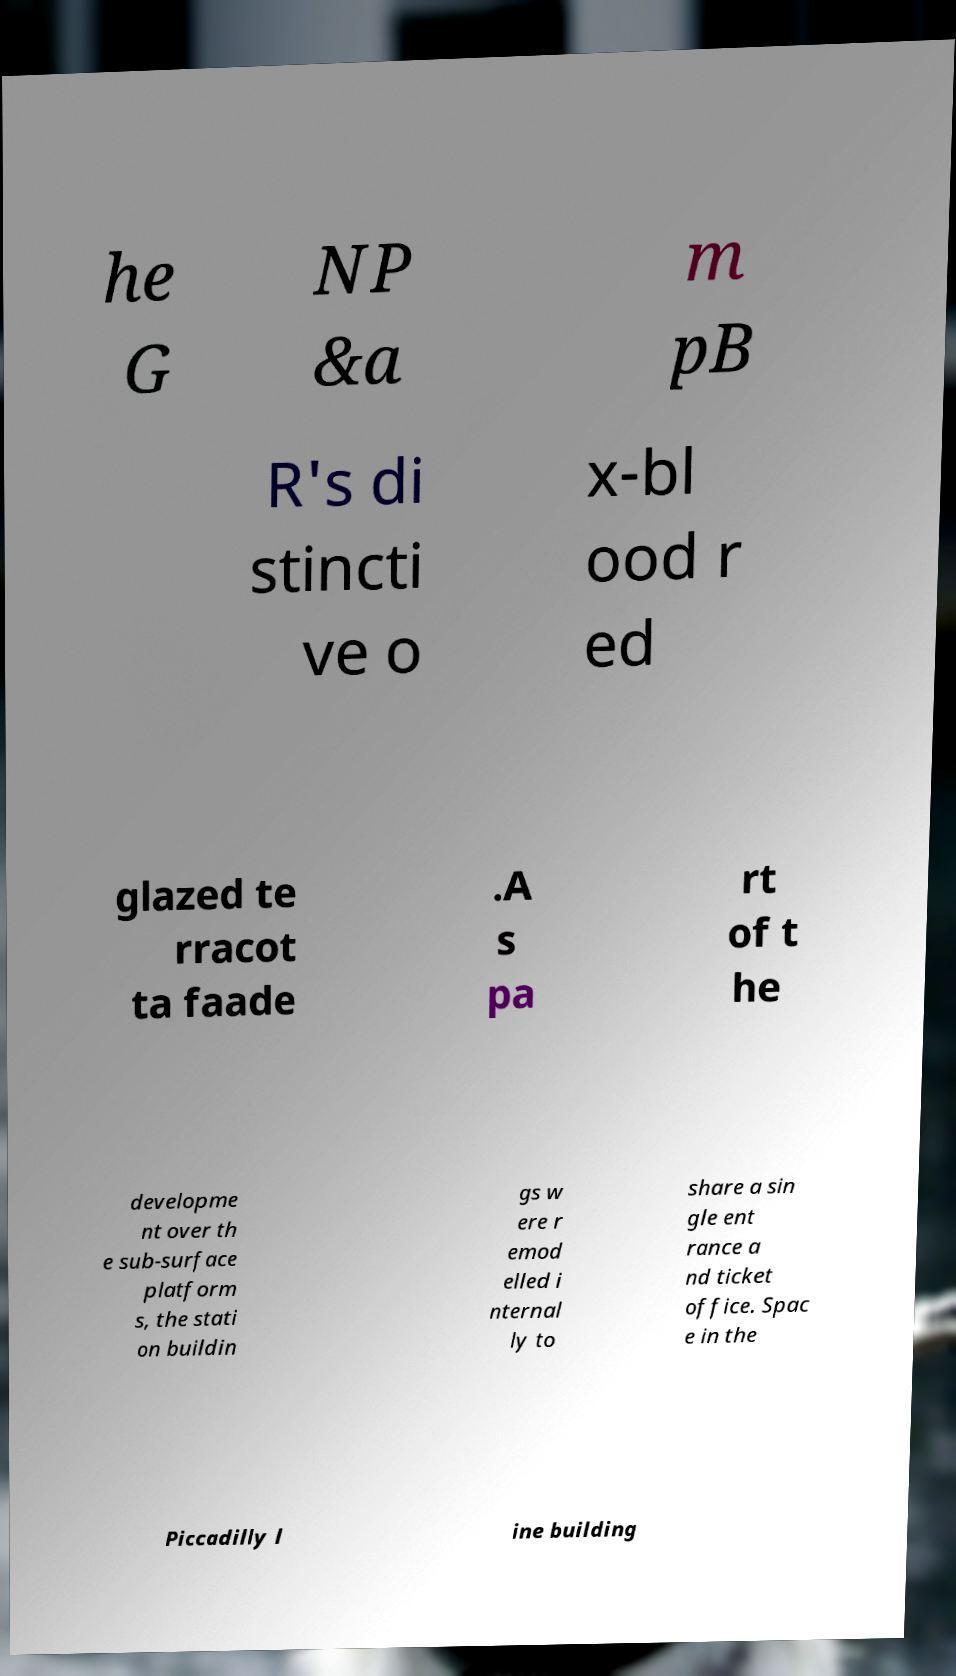Can you read and provide the text displayed in the image?This photo seems to have some interesting text. Can you extract and type it out for me? he G NP &a m pB R's di stincti ve o x-bl ood r ed glazed te rracot ta faade .A s pa rt of t he developme nt over th e sub-surface platform s, the stati on buildin gs w ere r emod elled i nternal ly to share a sin gle ent rance a nd ticket office. Spac e in the Piccadilly l ine building 